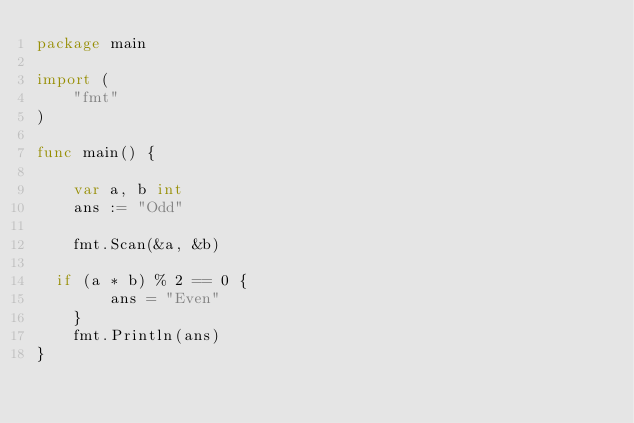<code> <loc_0><loc_0><loc_500><loc_500><_Go_>package main
 
import (
    "fmt"
)
 
func main() {
 
    var a, b int
    ans := "Odd"
 
    fmt.Scan(&a, &b)
 
  if (a * b) % 2 == 0 {
        ans = "Even"
    }
    fmt.Println(ans)
}</code> 